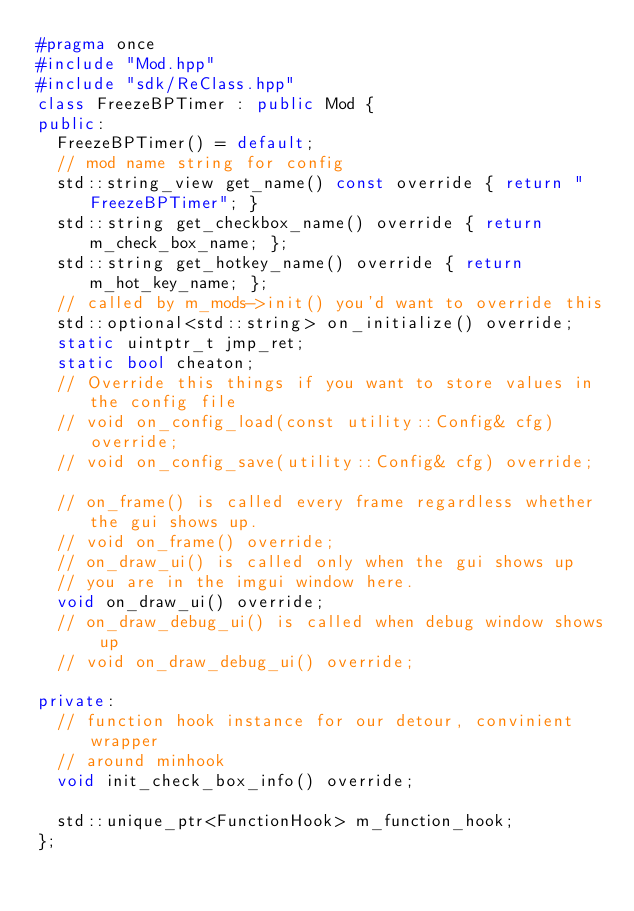Convert code to text. <code><loc_0><loc_0><loc_500><loc_500><_C++_>#pragma once
#include "Mod.hpp"
#include "sdk/ReClass.hpp"
class FreezeBPTimer : public Mod {
public:
  FreezeBPTimer() = default;
  // mod name string for config
  std::string_view get_name() const override { return "FreezeBPTimer"; }
  std::string get_checkbox_name() override { return m_check_box_name; };
  std::string get_hotkey_name() override { return m_hot_key_name; };
  // called by m_mods->init() you'd want to override this
  std::optional<std::string> on_initialize() override;
  static uintptr_t jmp_ret;
  static bool cheaton;
  // Override this things if you want to store values in the config file
  // void on_config_load(const utility::Config& cfg) override;
  // void on_config_save(utility::Config& cfg) override;

  // on_frame() is called every frame regardless whether the gui shows up.
  // void on_frame() override;
  // on_draw_ui() is called only when the gui shows up
  // you are in the imgui window here.
  void on_draw_ui() override;
  // on_draw_debug_ui() is called when debug window shows up
  // void on_draw_debug_ui() override;

private:
  // function hook instance for our detour, convinient wrapper
  // around minhook
  void init_check_box_info() override;

  std::unique_ptr<FunctionHook> m_function_hook;
};
</code> 